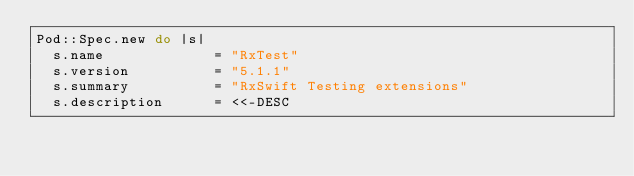Convert code to text. <code><loc_0><loc_0><loc_500><loc_500><_Ruby_>Pod::Spec.new do |s|
  s.name             = "RxTest"
  s.version          = "5.1.1"
  s.summary          = "RxSwift Testing extensions"
  s.description      = <<-DESC</code> 